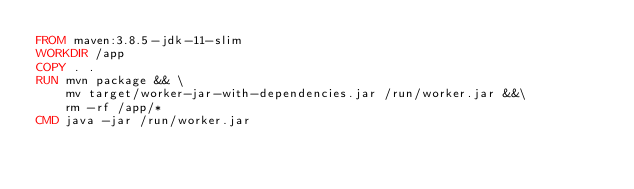Convert code to text. <code><loc_0><loc_0><loc_500><loc_500><_Dockerfile_>FROM maven:3.8.5-jdk-11-slim 
WORKDIR /app 
COPY . .
RUN mvn package && \ 
    mv target/worker-jar-with-dependencies.jar /run/worker.jar &&\        
    rm -rf /app/*
CMD java -jar /run/worker.jar
</code> 